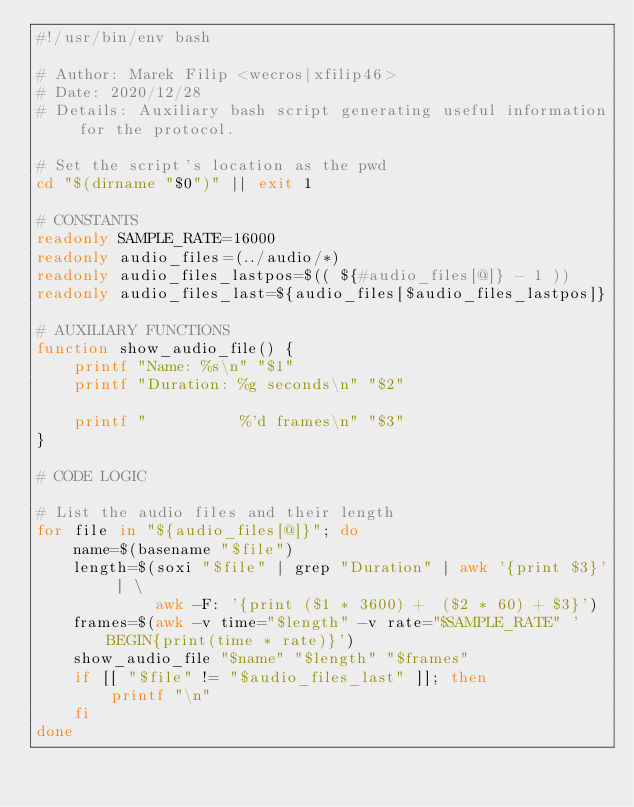<code> <loc_0><loc_0><loc_500><loc_500><_Bash_>#!/usr/bin/env bash

# Author: Marek Filip <wecros|xfilip46>
# Date: 2020/12/28
# Details: Auxiliary bash script generating useful information for the protocol.

# Set the script's location as the pwd
cd "$(dirname "$0")" || exit 1

# CONSTANTS
readonly SAMPLE_RATE=16000
readonly audio_files=(../audio/*)
readonly audio_files_lastpos=$(( ${#audio_files[@]} - 1 ))
readonly audio_files_last=${audio_files[$audio_files_lastpos]}

# AUXILIARY FUNCTIONS
function show_audio_file() {
    printf "Name: %s\n" "$1"
    printf "Duration: %g seconds\n" "$2"

    printf "          %'d frames\n" "$3"
}

# CODE LOGIC

# List the audio files and their length
for file in "${audio_files[@]}"; do
    name=$(basename "$file")
    length=$(soxi "$file" | grep "Duration" | awk '{print $3}' | \
             awk -F: '{print ($1 * 3600) +  ($2 * 60) + $3}')
    frames=$(awk -v time="$length" -v rate="$SAMPLE_RATE" 'BEGIN{print(time * rate)}')
    show_audio_file "$name" "$length" "$frames"
    if [[ "$file" != "$audio_files_last" ]]; then
        printf "\n"
    fi
done
</code> 